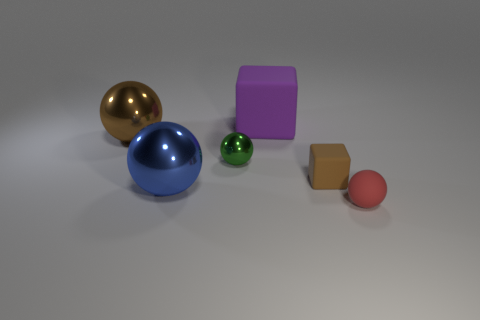Is the color of the shiny ball in front of the tiny green metallic object the same as the cube behind the big brown metal ball?
Offer a terse response. No. There is a big thing that is behind the green ball and in front of the large cube; what color is it?
Provide a short and direct response. Brown. Do the small brown thing and the large purple thing have the same material?
Make the answer very short. Yes. What number of small things are either balls or green objects?
Make the answer very short. 2. Are there any other things that are the same shape as the tiny brown rubber thing?
Your response must be concise. Yes. Are there any other things that are the same size as the green metal ball?
Ensure brevity in your answer.  Yes. There is a big cube that is the same material as the red ball; what color is it?
Your answer should be very brief. Purple. What is the color of the matte cube right of the purple matte block?
Keep it short and to the point. Brown. How many cylinders have the same color as the tiny cube?
Your response must be concise. 0. Is the number of purple rubber things to the right of the green thing less than the number of things left of the large blue ball?
Your answer should be very brief. No. 